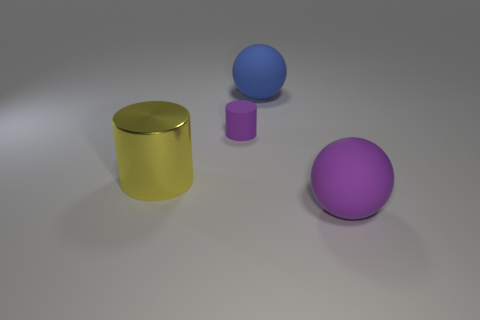Add 4 big spheres. How many objects exist? 8 Add 4 gray spheres. How many gray spheres exist? 4 Subtract 0 yellow blocks. How many objects are left? 4 Subtract all purple matte cylinders. Subtract all big purple rubber spheres. How many objects are left? 2 Add 3 large yellow cylinders. How many large yellow cylinders are left? 4 